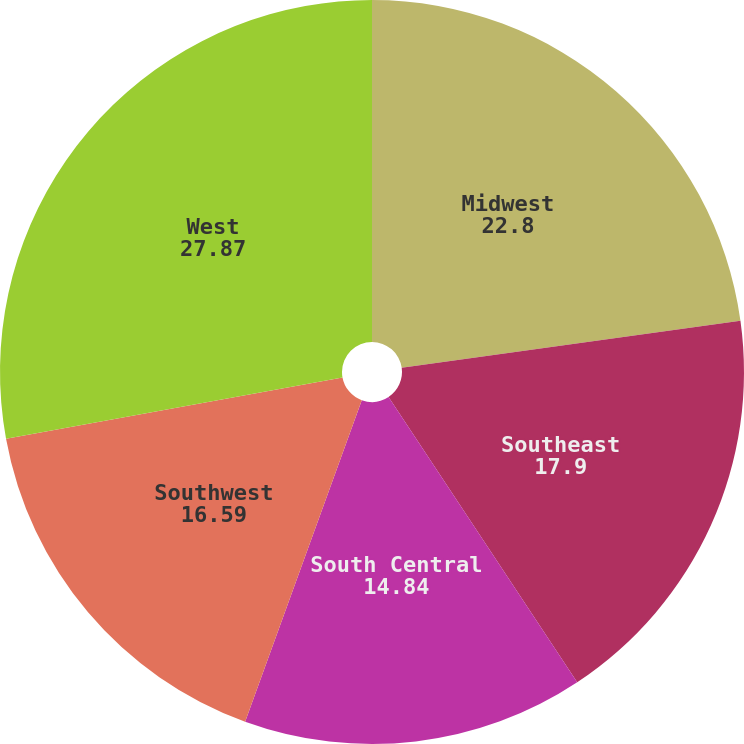Convert chart to OTSL. <chart><loc_0><loc_0><loc_500><loc_500><pie_chart><fcel>Midwest<fcel>Southeast<fcel>South Central<fcel>Southwest<fcel>West<nl><fcel>22.8%<fcel>17.9%<fcel>14.84%<fcel>16.59%<fcel>27.87%<nl></chart> 